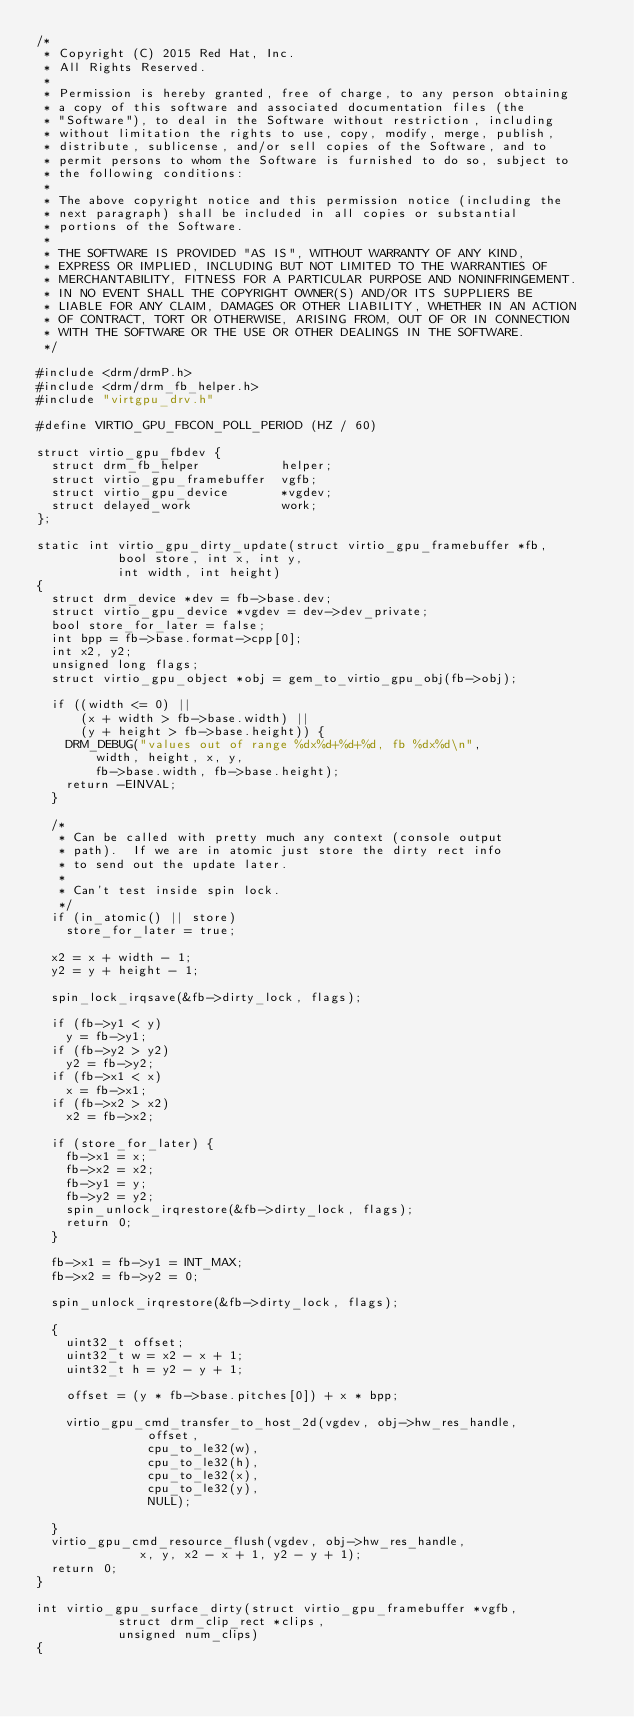<code> <loc_0><loc_0><loc_500><loc_500><_C_>/*
 * Copyright (C) 2015 Red Hat, Inc.
 * All Rights Reserved.
 *
 * Permission is hereby granted, free of charge, to any person obtaining
 * a copy of this software and associated documentation files (the
 * "Software"), to deal in the Software without restriction, including
 * without limitation the rights to use, copy, modify, merge, publish,
 * distribute, sublicense, and/or sell copies of the Software, and to
 * permit persons to whom the Software is furnished to do so, subject to
 * the following conditions:
 *
 * The above copyright notice and this permission notice (including the
 * next paragraph) shall be included in all copies or substantial
 * portions of the Software.
 *
 * THE SOFTWARE IS PROVIDED "AS IS", WITHOUT WARRANTY OF ANY KIND,
 * EXPRESS OR IMPLIED, INCLUDING BUT NOT LIMITED TO THE WARRANTIES OF
 * MERCHANTABILITY, FITNESS FOR A PARTICULAR PURPOSE AND NONINFRINGEMENT.
 * IN NO EVENT SHALL THE COPYRIGHT OWNER(S) AND/OR ITS SUPPLIERS BE
 * LIABLE FOR ANY CLAIM, DAMAGES OR OTHER LIABILITY, WHETHER IN AN ACTION
 * OF CONTRACT, TORT OR OTHERWISE, ARISING FROM, OUT OF OR IN CONNECTION
 * WITH THE SOFTWARE OR THE USE OR OTHER DEALINGS IN THE SOFTWARE.
 */

#include <drm/drmP.h>
#include <drm/drm_fb_helper.h>
#include "virtgpu_drv.h"

#define VIRTIO_GPU_FBCON_POLL_PERIOD (HZ / 60)

struct virtio_gpu_fbdev {
	struct drm_fb_helper           helper;
	struct virtio_gpu_framebuffer  vgfb;
	struct virtio_gpu_device       *vgdev;
	struct delayed_work            work;
};

static int virtio_gpu_dirty_update(struct virtio_gpu_framebuffer *fb,
				   bool store, int x, int y,
				   int width, int height)
{
	struct drm_device *dev = fb->base.dev;
	struct virtio_gpu_device *vgdev = dev->dev_private;
	bool store_for_later = false;
	int bpp = fb->base.format->cpp[0];
	int x2, y2;
	unsigned long flags;
	struct virtio_gpu_object *obj = gem_to_virtio_gpu_obj(fb->obj);

	if ((width <= 0) ||
	    (x + width > fb->base.width) ||
	    (y + height > fb->base.height)) {
		DRM_DEBUG("values out of range %dx%d+%d+%d, fb %dx%d\n",
			  width, height, x, y,
			  fb->base.width, fb->base.height);
		return -EINVAL;
	}

	/*
	 * Can be called with pretty much any context (console output
	 * path).  If we are in atomic just store the dirty rect info
	 * to send out the update later.
	 *
	 * Can't test inside spin lock.
	 */
	if (in_atomic() || store)
		store_for_later = true;

	x2 = x + width - 1;
	y2 = y + height - 1;

	spin_lock_irqsave(&fb->dirty_lock, flags);

	if (fb->y1 < y)
		y = fb->y1;
	if (fb->y2 > y2)
		y2 = fb->y2;
	if (fb->x1 < x)
		x = fb->x1;
	if (fb->x2 > x2)
		x2 = fb->x2;

	if (store_for_later) {
		fb->x1 = x;
		fb->x2 = x2;
		fb->y1 = y;
		fb->y2 = y2;
		spin_unlock_irqrestore(&fb->dirty_lock, flags);
		return 0;
	}

	fb->x1 = fb->y1 = INT_MAX;
	fb->x2 = fb->y2 = 0;

	spin_unlock_irqrestore(&fb->dirty_lock, flags);

	{
		uint32_t offset;
		uint32_t w = x2 - x + 1;
		uint32_t h = y2 - y + 1;

		offset = (y * fb->base.pitches[0]) + x * bpp;

		virtio_gpu_cmd_transfer_to_host_2d(vgdev, obj->hw_res_handle,
						   offset,
						   cpu_to_le32(w),
						   cpu_to_le32(h),
						   cpu_to_le32(x),
						   cpu_to_le32(y),
						   NULL);

	}
	virtio_gpu_cmd_resource_flush(vgdev, obj->hw_res_handle,
				      x, y, x2 - x + 1, y2 - y + 1);
	return 0;
}

int virtio_gpu_surface_dirty(struct virtio_gpu_framebuffer *vgfb,
			     struct drm_clip_rect *clips,
			     unsigned num_clips)
{</code> 